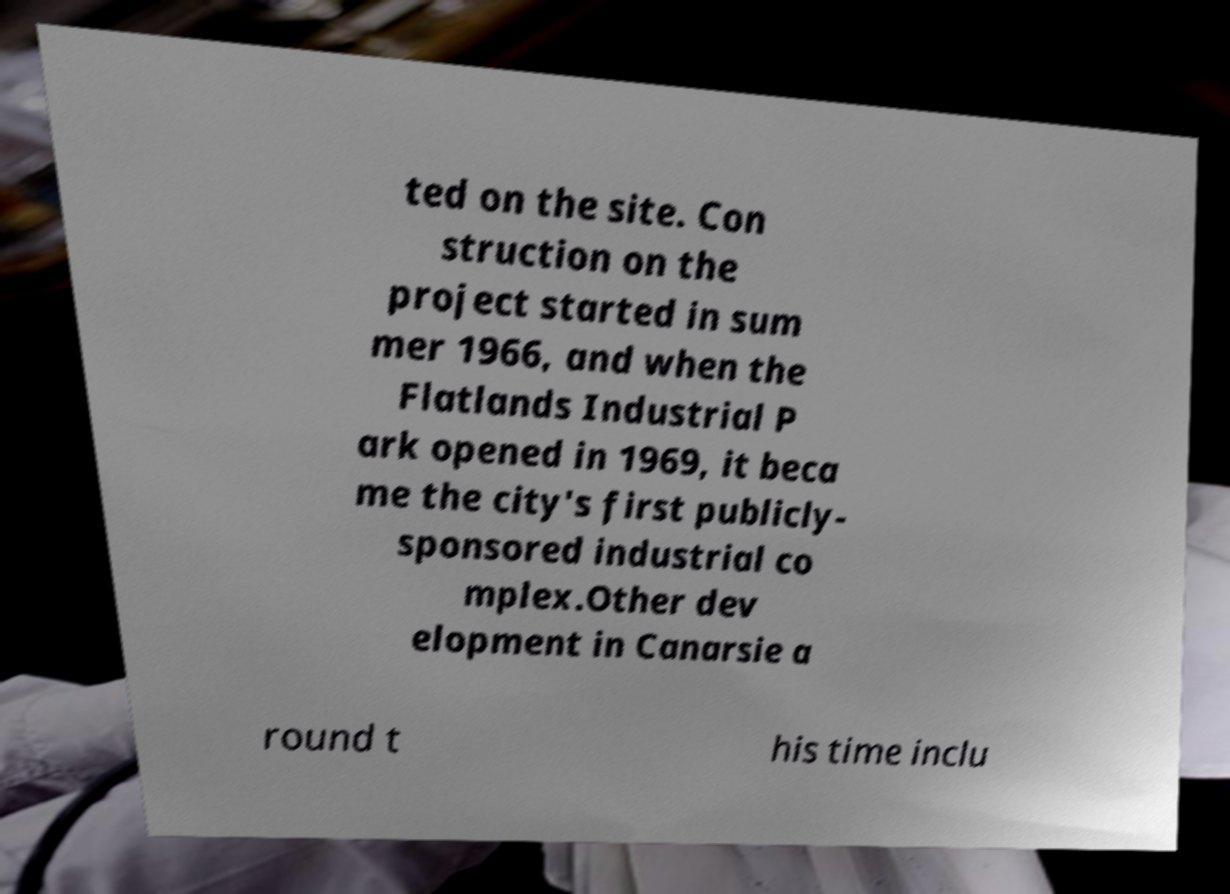Please identify and transcribe the text found in this image. ted on the site. Con struction on the project started in sum mer 1966, and when the Flatlands Industrial P ark opened in 1969, it beca me the city's first publicly- sponsored industrial co mplex.Other dev elopment in Canarsie a round t his time inclu 